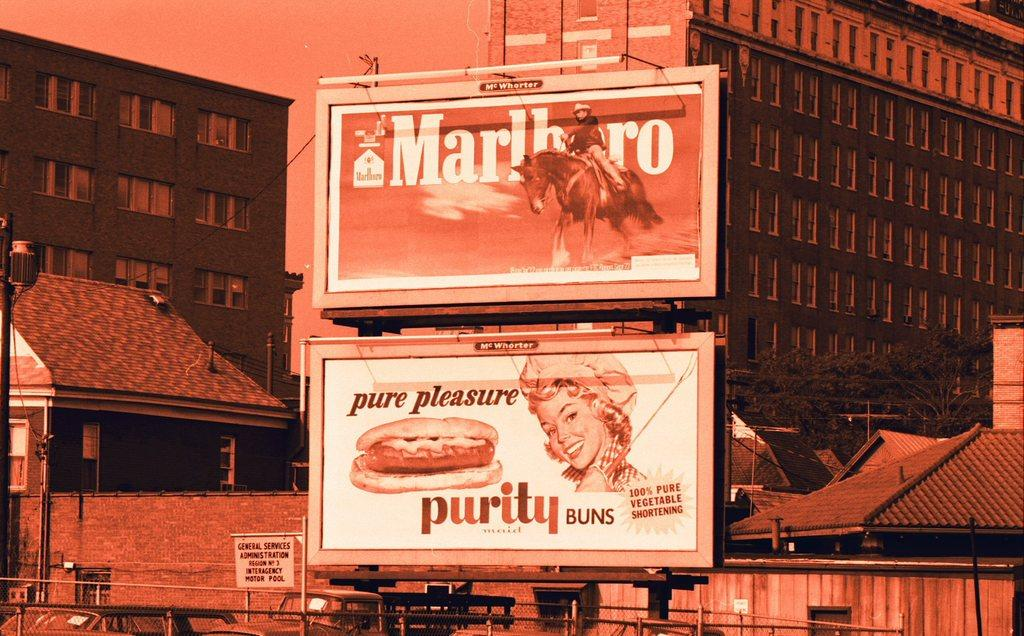<image>
Render a clear and concise summary of the photo. The billboards advertise Marlboro cigarettes and Purity buns. 